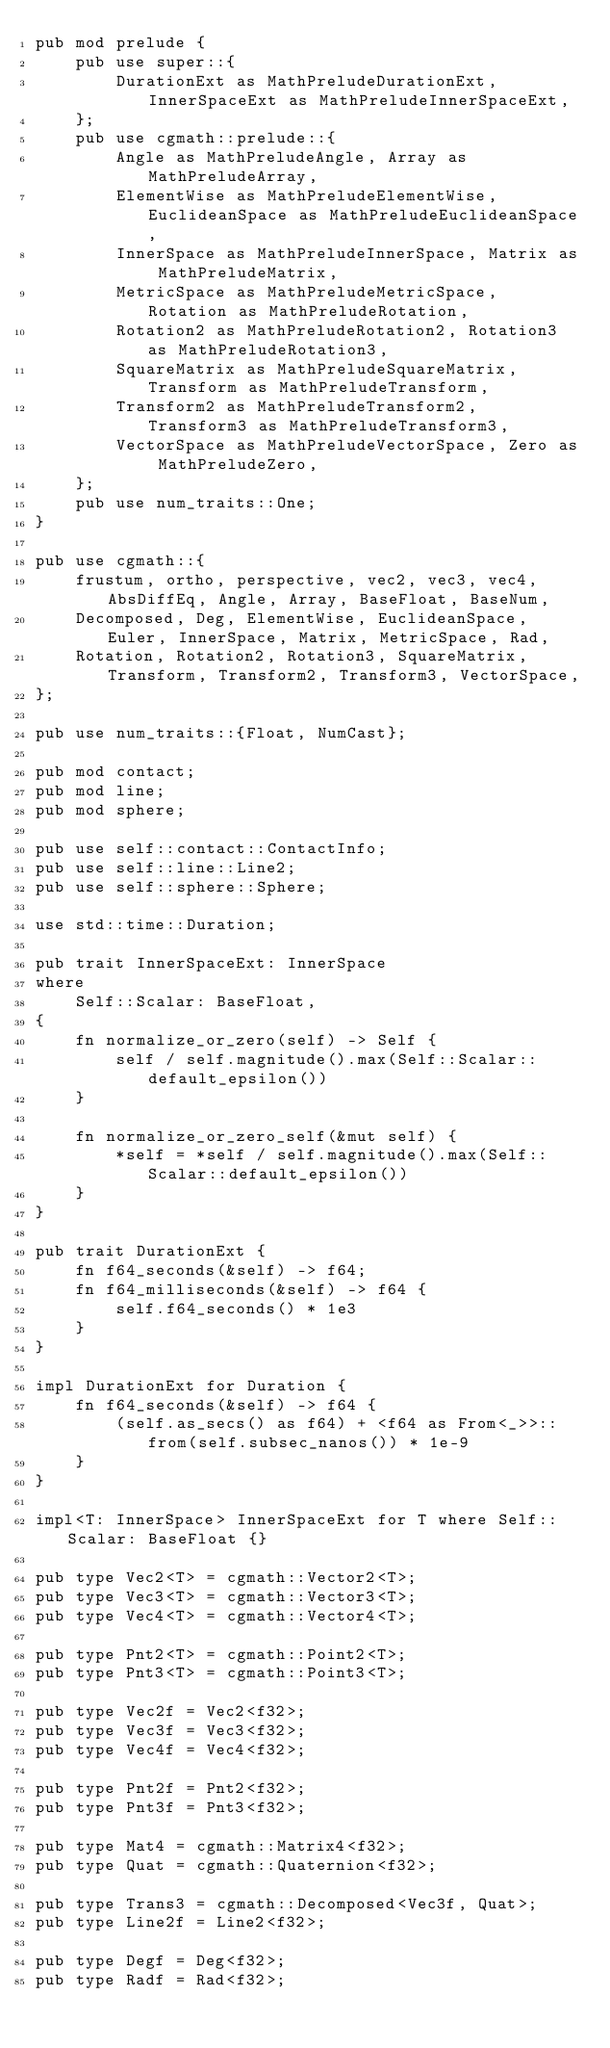<code> <loc_0><loc_0><loc_500><loc_500><_Rust_>pub mod prelude {
    pub use super::{
        DurationExt as MathPreludeDurationExt, InnerSpaceExt as MathPreludeInnerSpaceExt,
    };
    pub use cgmath::prelude::{
        Angle as MathPreludeAngle, Array as MathPreludeArray,
        ElementWise as MathPreludeElementWise, EuclideanSpace as MathPreludeEuclideanSpace,
        InnerSpace as MathPreludeInnerSpace, Matrix as MathPreludeMatrix,
        MetricSpace as MathPreludeMetricSpace, Rotation as MathPreludeRotation,
        Rotation2 as MathPreludeRotation2, Rotation3 as MathPreludeRotation3,
        SquareMatrix as MathPreludeSquareMatrix, Transform as MathPreludeTransform,
        Transform2 as MathPreludeTransform2, Transform3 as MathPreludeTransform3,
        VectorSpace as MathPreludeVectorSpace, Zero as MathPreludeZero,
    };
    pub use num_traits::One;
}

pub use cgmath::{
    frustum, ortho, perspective, vec2, vec3, vec4, AbsDiffEq, Angle, Array, BaseFloat, BaseNum,
    Decomposed, Deg, ElementWise, EuclideanSpace, Euler, InnerSpace, Matrix, MetricSpace, Rad,
    Rotation, Rotation2, Rotation3, SquareMatrix, Transform, Transform2, Transform3, VectorSpace,
};

pub use num_traits::{Float, NumCast};

pub mod contact;
pub mod line;
pub mod sphere;

pub use self::contact::ContactInfo;
pub use self::line::Line2;
pub use self::sphere::Sphere;

use std::time::Duration;

pub trait InnerSpaceExt: InnerSpace
where
    Self::Scalar: BaseFloat,
{
    fn normalize_or_zero(self) -> Self {
        self / self.magnitude().max(Self::Scalar::default_epsilon())
    }

    fn normalize_or_zero_self(&mut self) {
        *self = *self / self.magnitude().max(Self::Scalar::default_epsilon())
    }
}

pub trait DurationExt {
    fn f64_seconds(&self) -> f64;
    fn f64_milliseconds(&self) -> f64 {
        self.f64_seconds() * 1e3
    }
}

impl DurationExt for Duration {
    fn f64_seconds(&self) -> f64 {
        (self.as_secs() as f64) + <f64 as From<_>>::from(self.subsec_nanos()) * 1e-9
    }
}

impl<T: InnerSpace> InnerSpaceExt for T where Self::Scalar: BaseFloat {}

pub type Vec2<T> = cgmath::Vector2<T>;
pub type Vec3<T> = cgmath::Vector3<T>;
pub type Vec4<T> = cgmath::Vector4<T>;

pub type Pnt2<T> = cgmath::Point2<T>;
pub type Pnt3<T> = cgmath::Point3<T>;

pub type Vec2f = Vec2<f32>;
pub type Vec3f = Vec3<f32>;
pub type Vec4f = Vec4<f32>;

pub type Pnt2f = Pnt2<f32>;
pub type Pnt3f = Pnt3<f32>;

pub type Mat4 = cgmath::Matrix4<f32>;
pub type Quat = cgmath::Quaternion<f32>;

pub type Trans3 = cgmath::Decomposed<Vec3f, Quat>;
pub type Line2f = Line2<f32>;

pub type Degf = Deg<f32>;
pub type Radf = Rad<f32>;
</code> 